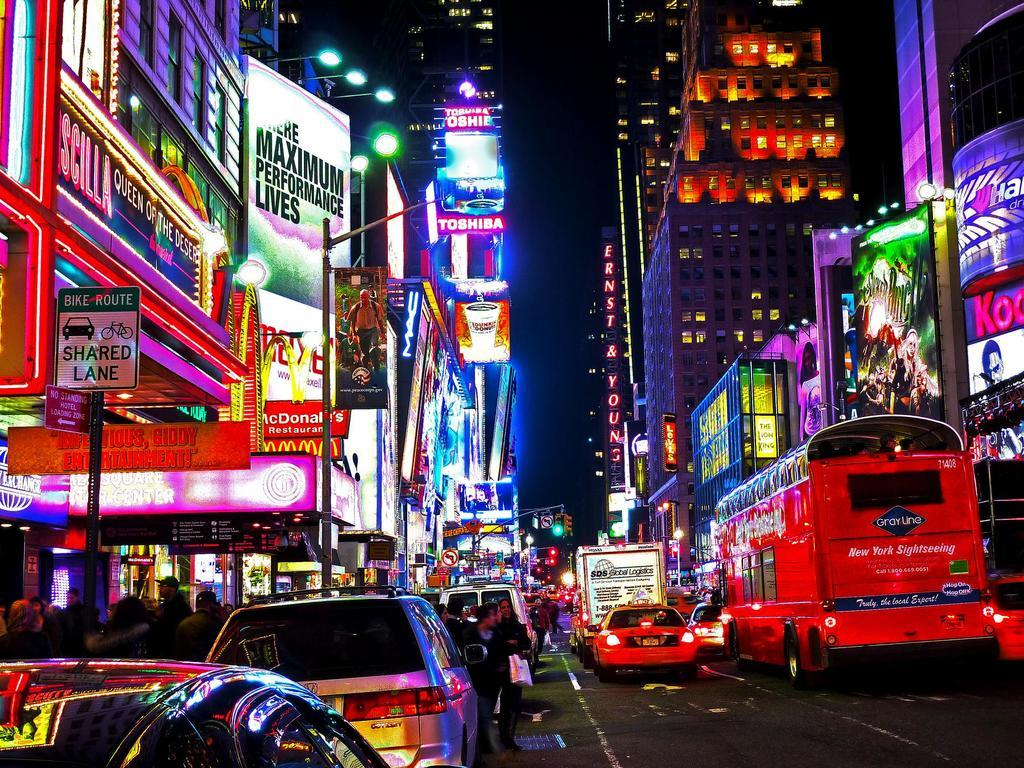<image>
Provide a brief description of the given image. A crowded city street with signs such as BIKE ROUTE SHARED LANE. 